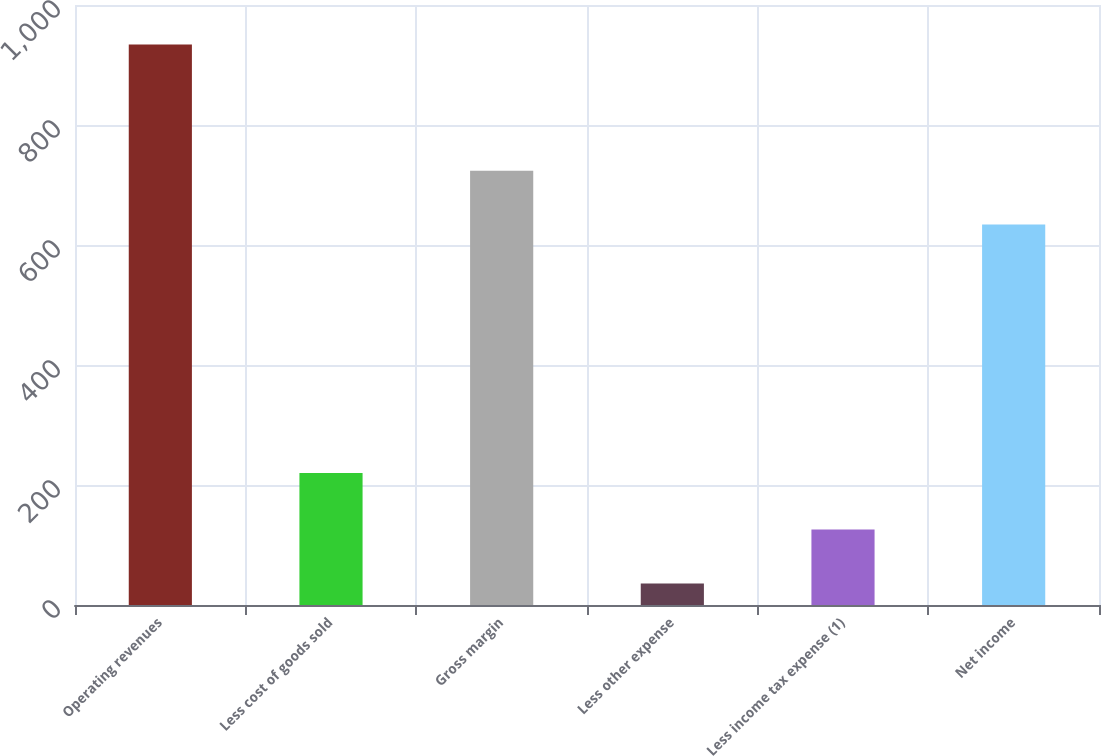Convert chart to OTSL. <chart><loc_0><loc_0><loc_500><loc_500><bar_chart><fcel>Operating revenues<fcel>Less cost of goods sold<fcel>Gross margin<fcel>Less other expense<fcel>Less income tax expense (1)<fcel>Net income<nl><fcel>934<fcel>220<fcel>723.8<fcel>36<fcel>125.8<fcel>634<nl></chart> 